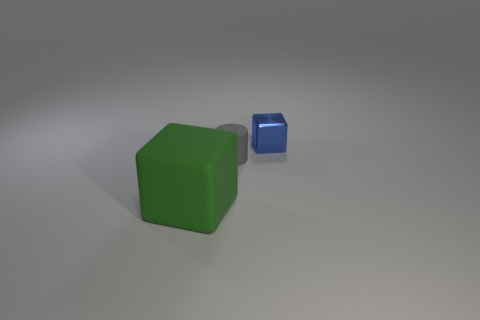Add 3 gray rubber things. How many objects exist? 6 Subtract all cylinders. How many objects are left? 2 Add 3 large gray rubber cylinders. How many large gray rubber cylinders exist? 3 Subtract 0 brown blocks. How many objects are left? 3 Subtract all tiny cubes. Subtract all big things. How many objects are left? 1 Add 3 green rubber blocks. How many green rubber blocks are left? 4 